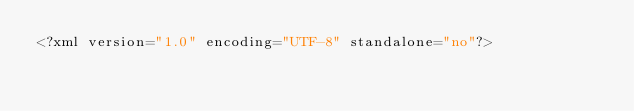<code> <loc_0><loc_0><loc_500><loc_500><_HTML_><?xml version="1.0" encoding="UTF-8" standalone="no"?></code> 